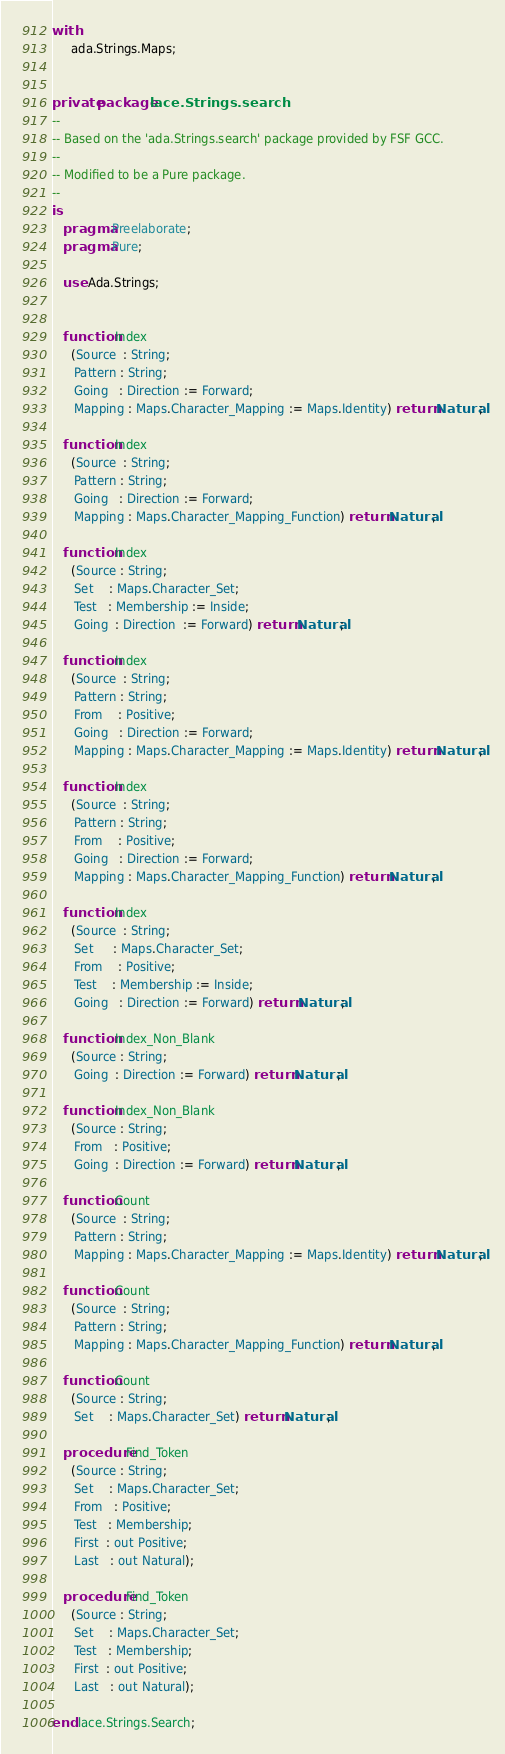Convert code to text. <code><loc_0><loc_0><loc_500><loc_500><_Ada_>with
     ada.Strings.Maps;


private package lace.Strings.search
--
-- Based on the 'ada.Strings.search' package provided by FSF GCC.
--
-- Modified to be a Pure package.
--
is
   pragma Preelaborate;
   pragma Pure;

   use Ada.Strings;


   function Index
     (Source  : String;
      Pattern : String;
      Going   : Direction := Forward;
      Mapping : Maps.Character_Mapping := Maps.Identity) return Natural;

   function Index
     (Source  : String;
      Pattern : String;
      Going   : Direction := Forward;
      Mapping : Maps.Character_Mapping_Function) return Natural;

   function Index
     (Source : String;
      Set    : Maps.Character_Set;
      Test   : Membership := Inside;
      Going  : Direction  := Forward) return Natural;

   function Index
     (Source  : String;
      Pattern : String;
      From    : Positive;
      Going   : Direction := Forward;
      Mapping : Maps.Character_Mapping := Maps.Identity) return Natural;

   function Index
     (Source  : String;
      Pattern : String;
      From    : Positive;
      Going   : Direction := Forward;
      Mapping : Maps.Character_Mapping_Function) return Natural;

   function Index
     (Source  : String;
      Set     : Maps.Character_Set;
      From    : Positive;
      Test    : Membership := Inside;
      Going   : Direction := Forward) return Natural;

   function Index_Non_Blank
     (Source : String;
      Going  : Direction := Forward) return Natural;

   function Index_Non_Blank
     (Source : String;
      From   : Positive;
      Going  : Direction := Forward) return Natural;

   function Count
     (Source  : String;
      Pattern : String;
      Mapping : Maps.Character_Mapping := Maps.Identity) return Natural;

   function Count
     (Source  : String;
      Pattern : String;
      Mapping : Maps.Character_Mapping_Function) return Natural;

   function Count
     (Source : String;
      Set    : Maps.Character_Set) return Natural;

   procedure Find_Token
     (Source : String;
      Set    : Maps.Character_Set;
      From   : Positive;
      Test   : Membership;
      First  : out Positive;
      Last   : out Natural);

   procedure Find_Token
     (Source : String;
      Set    : Maps.Character_Set;
      Test   : Membership;
      First  : out Positive;
      Last   : out Natural);

end lace.Strings.Search;
</code> 